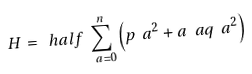<formula> <loc_0><loc_0><loc_500><loc_500>H = \ h a l f \sum _ { \ a = 0 } ^ { n } \left ( p _ { \ } a ^ { 2 } + a _ { \ } a q _ { \ } a ^ { 2 } \right )</formula> 